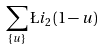<formula> <loc_0><loc_0><loc_500><loc_500>\sum _ { \{ u \} } \L i _ { 2 } \left ( 1 - u \right )</formula> 